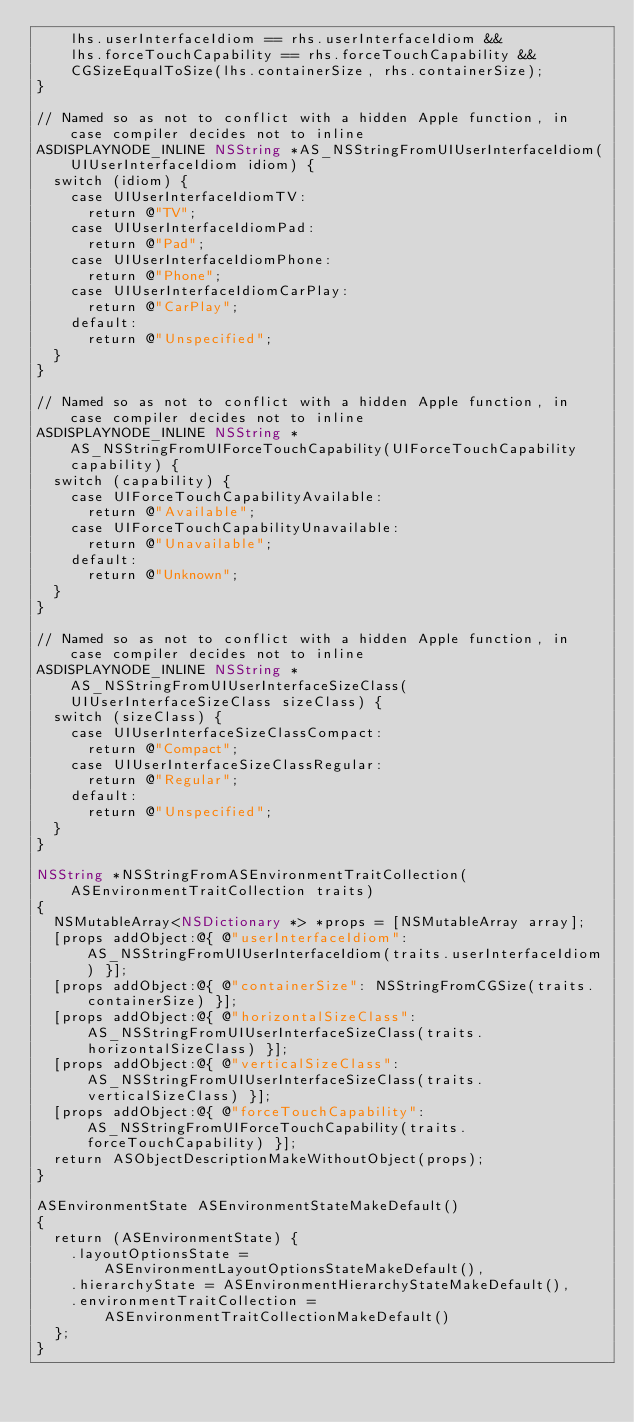<code> <loc_0><loc_0><loc_500><loc_500><_ObjectiveC_>    lhs.userInterfaceIdiom == rhs.userInterfaceIdiom &&
    lhs.forceTouchCapability == rhs.forceTouchCapability &&
    CGSizeEqualToSize(lhs.containerSize, rhs.containerSize);
}

// Named so as not to conflict with a hidden Apple function, in case compiler decides not to inline
ASDISPLAYNODE_INLINE NSString *AS_NSStringFromUIUserInterfaceIdiom(UIUserInterfaceIdiom idiom) {
  switch (idiom) {
    case UIUserInterfaceIdiomTV:
      return @"TV";
    case UIUserInterfaceIdiomPad:
      return @"Pad";
    case UIUserInterfaceIdiomPhone:
      return @"Phone";
    case UIUserInterfaceIdiomCarPlay:
      return @"CarPlay";
    default:
      return @"Unspecified";
  }
}

// Named so as not to conflict with a hidden Apple function, in case compiler decides not to inline
ASDISPLAYNODE_INLINE NSString *AS_NSStringFromUIForceTouchCapability(UIForceTouchCapability capability) {
  switch (capability) {
    case UIForceTouchCapabilityAvailable:
      return @"Available";
    case UIForceTouchCapabilityUnavailable:
      return @"Unavailable";
    default:
      return @"Unknown";
  }
}

// Named so as not to conflict with a hidden Apple function, in case compiler decides not to inline
ASDISPLAYNODE_INLINE NSString *AS_NSStringFromUIUserInterfaceSizeClass(UIUserInterfaceSizeClass sizeClass) {
  switch (sizeClass) {
    case UIUserInterfaceSizeClassCompact:
      return @"Compact";
    case UIUserInterfaceSizeClassRegular:
      return @"Regular";
    default:
      return @"Unspecified";
  }
}

NSString *NSStringFromASEnvironmentTraitCollection(ASEnvironmentTraitCollection traits)
{
  NSMutableArray<NSDictionary *> *props = [NSMutableArray array];
  [props addObject:@{ @"userInterfaceIdiom": AS_NSStringFromUIUserInterfaceIdiom(traits.userInterfaceIdiom) }];
  [props addObject:@{ @"containerSize": NSStringFromCGSize(traits.containerSize) }];
  [props addObject:@{ @"horizontalSizeClass": AS_NSStringFromUIUserInterfaceSizeClass(traits.horizontalSizeClass) }];
  [props addObject:@{ @"verticalSizeClass": AS_NSStringFromUIUserInterfaceSizeClass(traits.verticalSizeClass) }];
  [props addObject:@{ @"forceTouchCapability": AS_NSStringFromUIForceTouchCapability(traits.forceTouchCapability) }];
  return ASObjectDescriptionMakeWithoutObject(props);
}

ASEnvironmentState ASEnvironmentStateMakeDefault()
{
  return (ASEnvironmentState) {
    .layoutOptionsState = ASEnvironmentLayoutOptionsStateMakeDefault(),
    .hierarchyState = ASEnvironmentHierarchyStateMakeDefault(),
    .environmentTraitCollection = ASEnvironmentTraitCollectionMakeDefault()
  };
}

</code> 